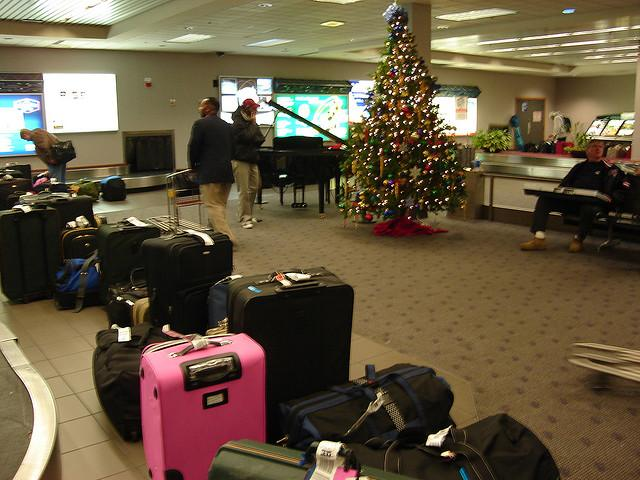A baggage carousel is a device generally at where? airport 